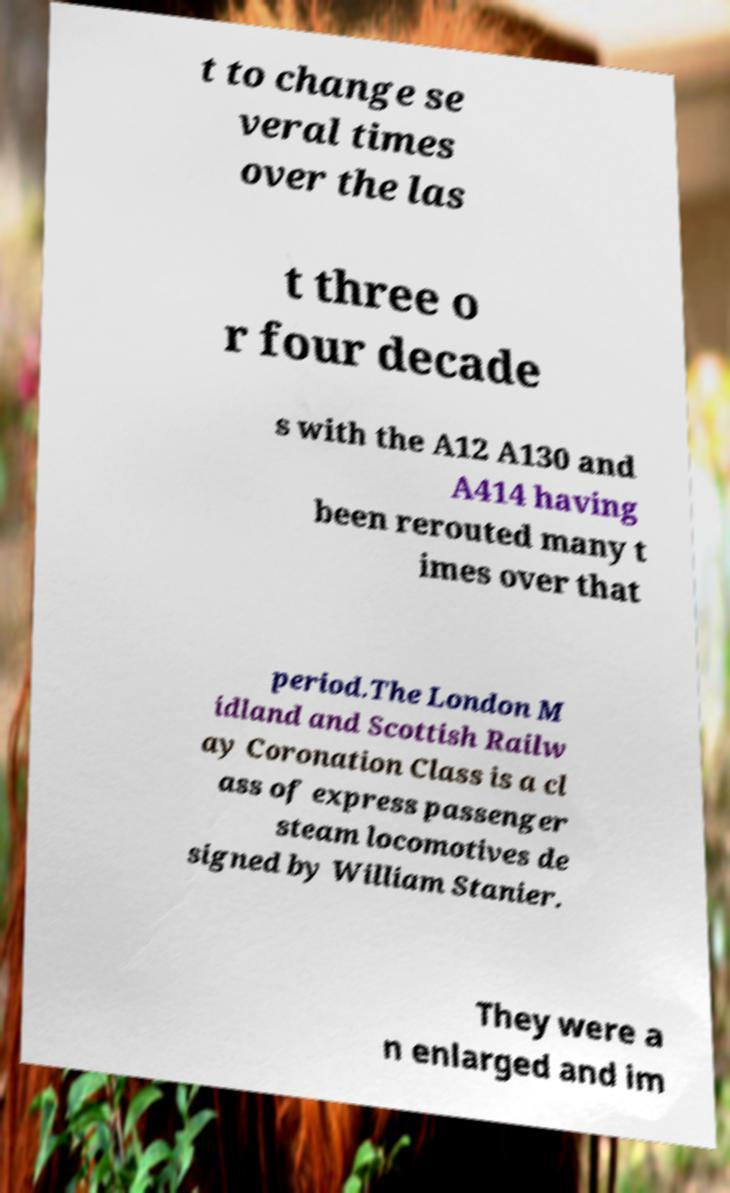I need the written content from this picture converted into text. Can you do that? t to change se veral times over the las t three o r four decade s with the A12 A130 and A414 having been rerouted many t imes over that period.The London M idland and Scottish Railw ay Coronation Class is a cl ass of express passenger steam locomotives de signed by William Stanier. They were a n enlarged and im 